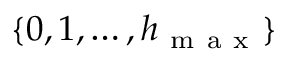<formula> <loc_0><loc_0><loc_500><loc_500>\{ 0 , 1 , \dots , h _ { m a x } \}</formula> 